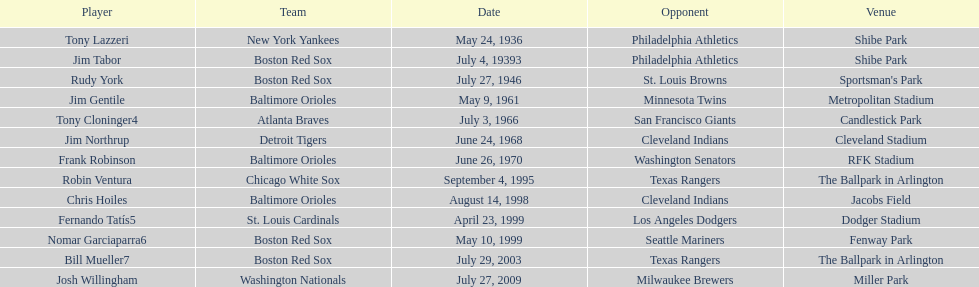Who was the adversary for the boston red sox on july 27, 1946? St. Louis Browns. 